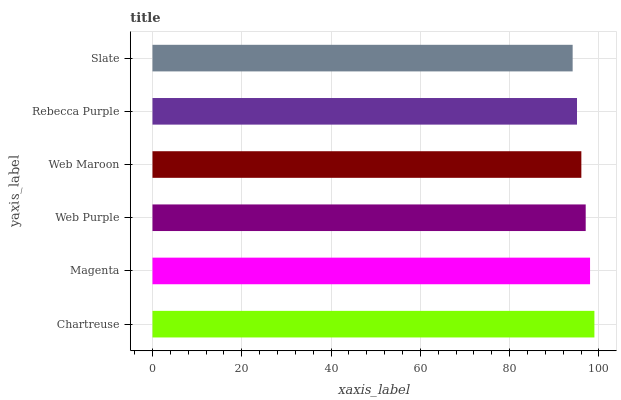Is Slate the minimum?
Answer yes or no. Yes. Is Chartreuse the maximum?
Answer yes or no. Yes. Is Magenta the minimum?
Answer yes or no. No. Is Magenta the maximum?
Answer yes or no. No. Is Chartreuse greater than Magenta?
Answer yes or no. Yes. Is Magenta less than Chartreuse?
Answer yes or no. Yes. Is Magenta greater than Chartreuse?
Answer yes or no. No. Is Chartreuse less than Magenta?
Answer yes or no. No. Is Web Purple the high median?
Answer yes or no. Yes. Is Web Maroon the low median?
Answer yes or no. Yes. Is Slate the high median?
Answer yes or no. No. Is Chartreuse the low median?
Answer yes or no. No. 